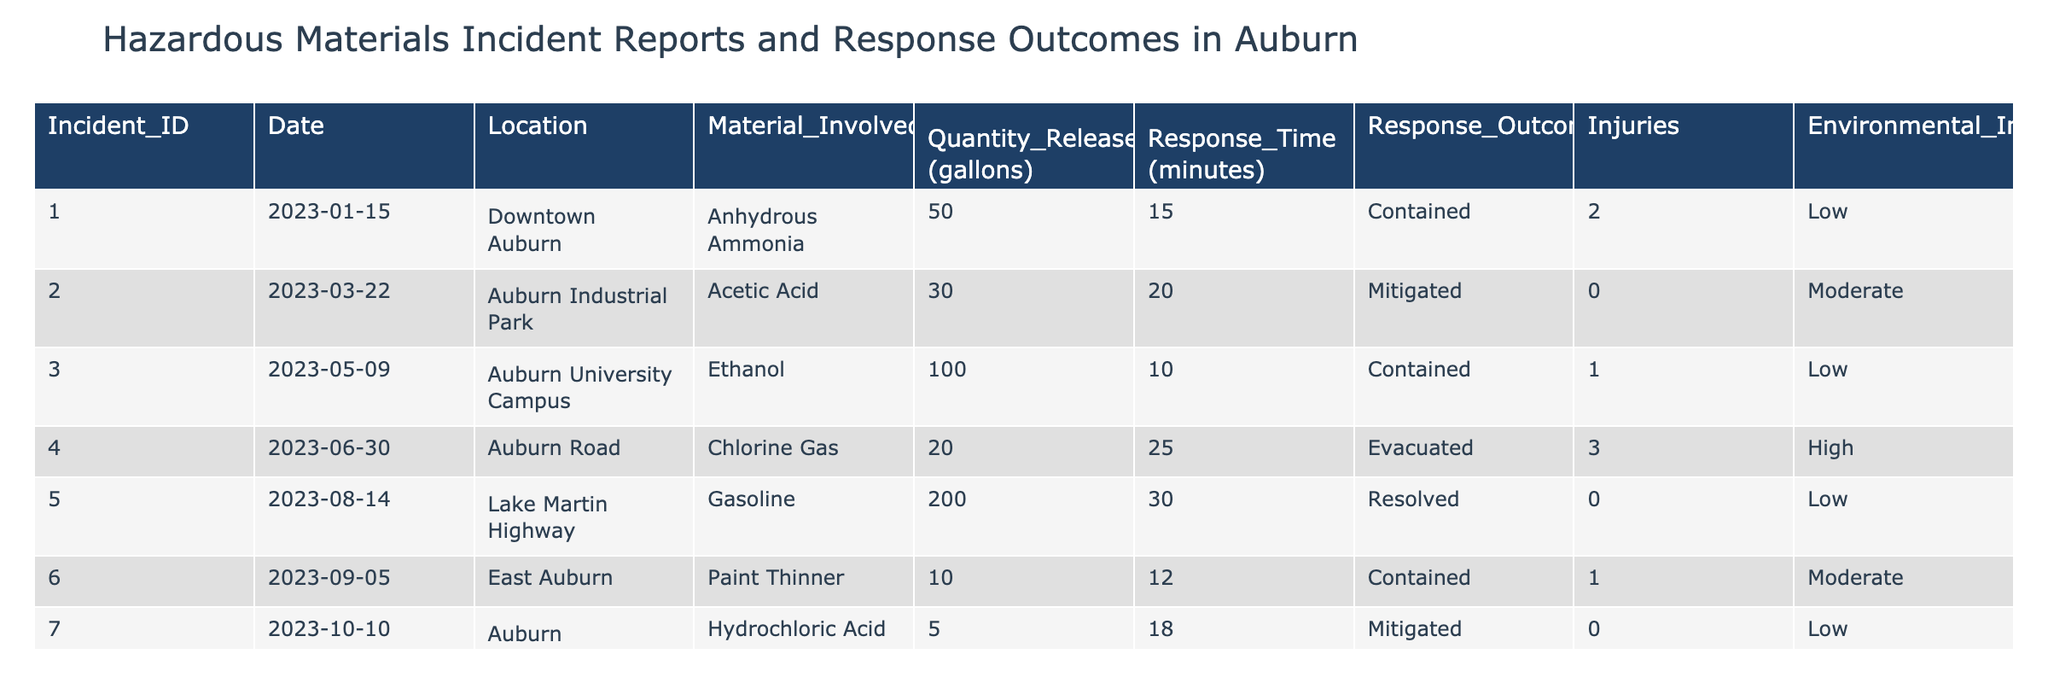What is the material involved in the incident on June 30, 2023? Looking at the date column for June 30, 2023, we find the material listed in that row. The material involved is Chlorine Gas.
Answer: Chlorine Gas How many incidents involved injuries? By reviewing the Injuries column, I see that there are three incidents where injuries occurred: Incident ID 001 (2 injuries), Incident ID 004 (3 injuries), and Incident ID 006 (1 injury). Therefore, there are 3 incidents in total that involved injuries.
Answer: 3 What is the average response time for all incidents? To find the average response time, I first sum the response times: 15 + 20 + 10 + 25 + 30 + 12 + 18 = 130 minutes. Then, I divide by the total number of incidents, which is 7. Thus, the average response time is 130 / 7 ≈ 18.57 minutes.
Answer: 18.57 Did any incident on the Auburn University Campus have an environmental impact described as high? By checking the entry for the Auburn University Campus, I see only one incident (ID 003) and its environmental impact is noted as low. Therefore, there is no incident at this location with a high environmental impact.
Answer: No What is the total quantity of hazardous materials released across all incidents? To calculate the total quantity released, I add the quantities from each incident: 50 + 30 + 100 + 20 + 200 + 10 + 5 = 415 gallons. Thus, the total quantity of hazardous materials released is 415 gallons.
Answer: 415 gallons Which incident had the longest response time and what was that time? By examining the Response Time column, the longest response time is found under Auburn Road with a value of 25 minutes. Therefore, the incident with the longest response time is Incident ID 004 with 25 minutes.
Answer: 25 minutes Was the response outcome of the incident involving Hydrochloric Acid classified as contained? Looking at the Response Outcome for Incident ID 007, which involves Hydrochloric Acid, the information indicates it was mitigated, not contained. Therefore, the response outcome is not classified as contained.
Answer: No How many incidents caused a moderate environmental impact? Checking the Environmental Impact column, I see that the incidents with moderate impacts are Incident ID 002 (Acetic Acid 30 gallons) and Incident ID 006 (Paint Thinner 10 gallons). That results in a total of 2 incidents that caused moderate environmental impact.
Answer: 2 